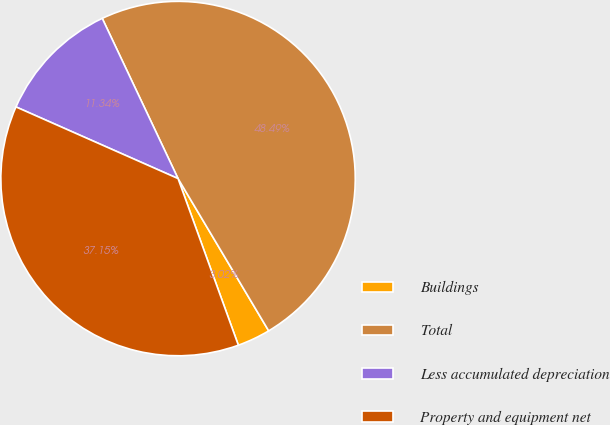Convert chart to OTSL. <chart><loc_0><loc_0><loc_500><loc_500><pie_chart><fcel>Buildings<fcel>Total<fcel>Less accumulated depreciation<fcel>Property and equipment net<nl><fcel>3.02%<fcel>48.49%<fcel>11.34%<fcel>37.15%<nl></chart> 